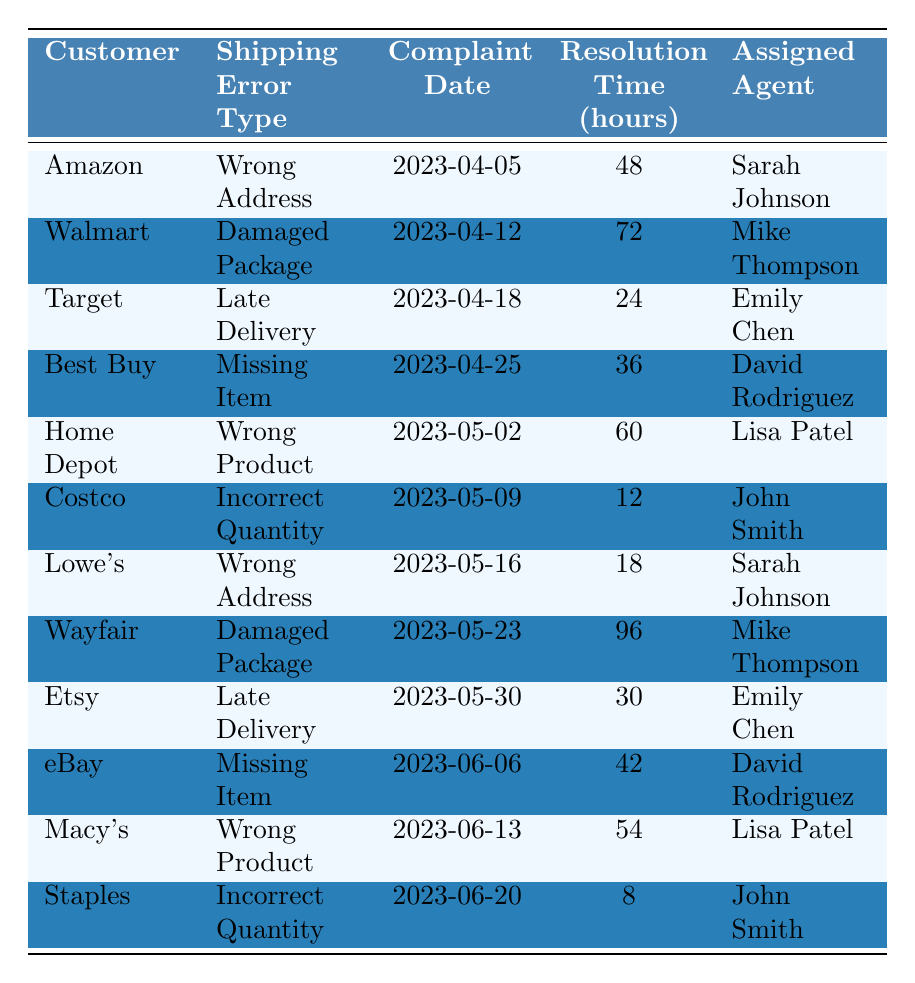What is the shipping error type for Walmart? The table lists Walmart and specifies the shipping error type associated with it, which is "Damaged Package."
Answer: Damaged Package Who is the assigned agent for the complaint from Home Depot? By looking at the Home Depot entry in the table, we can see that the assigned agent for their complaint is "Lisa Patel."
Answer: Lisa Patel What is the total resolution time for all complaints? To find the total resolution time, we add up all the resolution times: 48 + 72 + 24 + 36 + 60 + 12 + 18 + 96 + 30 + 42 + 54 + 8 = 432 hours.
Answer: 432 hours How many complaints were resolved in less than 24 hours? We can identify the resolution times in the table that are less than 24 hours. The only entry is for Staples, with a resolution time of 8 hours. Therefore, there is 1 complaint.
Answer: 1 complaint Which shipping error type took the longest to resolve? Examining the resolution times in the table, "Wayfair" has the highest resolution time of 96 hours for "Damaged Package," making it the longest.
Answer: Damaged Package Is there a shipping error type that has multiple entries in the table? Looking at the table, "Wrong Address" occurs twice (Amazon and Lowe's), confirming that at least one shipping error type has multiple entries.
Answer: Yes What is the average resolution time for complaints handled by Sarah Johnson? Sarah Johnson's complaints are from Amazon (48 hours) and Lowe's (18 hours). The total is 48 + 18 = 66 hours and there are 2 complaints. Therefore, the average is 66 / 2 = 33 hours.
Answer: 33 hours How many agents handled complaints for "Missing Item" errors? The table shows two entries for the "Missing Item" error type: Best Buy (David Rodriguez) and eBay (David Rodriguez). Since both are assigned to the same agent, only 1 unique agent handled it.
Answer: 1 agent What percentage of complaints were resolved in more than 50 hours? There are 12 entries in total. The complaints resolved in more than 50 hours are for Walmart (72), Wayfair (96), Home Depot (60), and Macy's (54), totaling 4 complaints. The percentage is (4/12) * 100 = 33.33%.
Answer: 33.33% Identify the customers associated with "Late Delivery" errors. The table shows two customers with "Late Delivery": Target and Etsy, as indicated in their respective rows.
Answer: Target and Etsy 